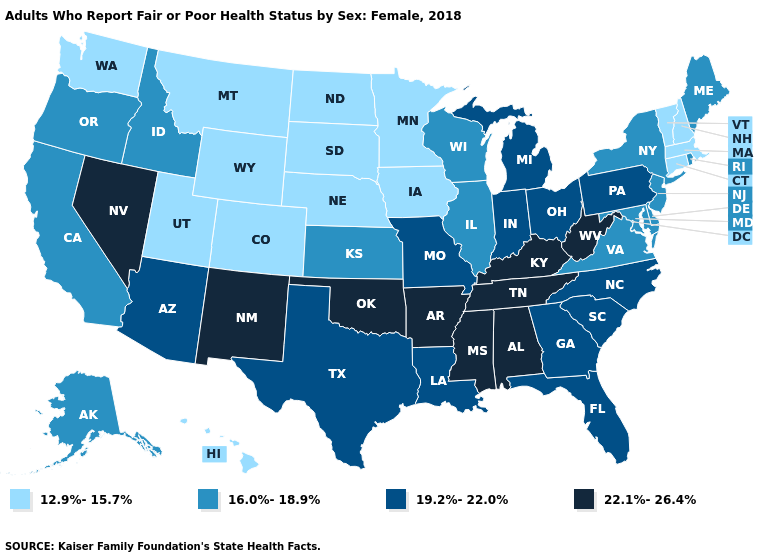Which states have the highest value in the USA?
Quick response, please. Alabama, Arkansas, Kentucky, Mississippi, Nevada, New Mexico, Oklahoma, Tennessee, West Virginia. What is the highest value in the USA?
Quick response, please. 22.1%-26.4%. What is the lowest value in states that border Idaho?
Quick response, please. 12.9%-15.7%. Among the states that border New Jersey , which have the lowest value?
Keep it brief. Delaware, New York. Name the states that have a value in the range 22.1%-26.4%?
Give a very brief answer. Alabama, Arkansas, Kentucky, Mississippi, Nevada, New Mexico, Oklahoma, Tennessee, West Virginia. What is the value of Iowa?
Give a very brief answer. 12.9%-15.7%. Which states hav the highest value in the Northeast?
Be succinct. Pennsylvania. Which states have the highest value in the USA?
Write a very short answer. Alabama, Arkansas, Kentucky, Mississippi, Nevada, New Mexico, Oklahoma, Tennessee, West Virginia. What is the lowest value in states that border Kansas?
Answer briefly. 12.9%-15.7%. Name the states that have a value in the range 22.1%-26.4%?
Keep it brief. Alabama, Arkansas, Kentucky, Mississippi, Nevada, New Mexico, Oklahoma, Tennessee, West Virginia. Does South Dakota have the same value as Washington?
Give a very brief answer. Yes. How many symbols are there in the legend?
Quick response, please. 4. Does Ohio have the same value as Texas?
Concise answer only. Yes. What is the lowest value in the USA?
Quick response, please. 12.9%-15.7%. 